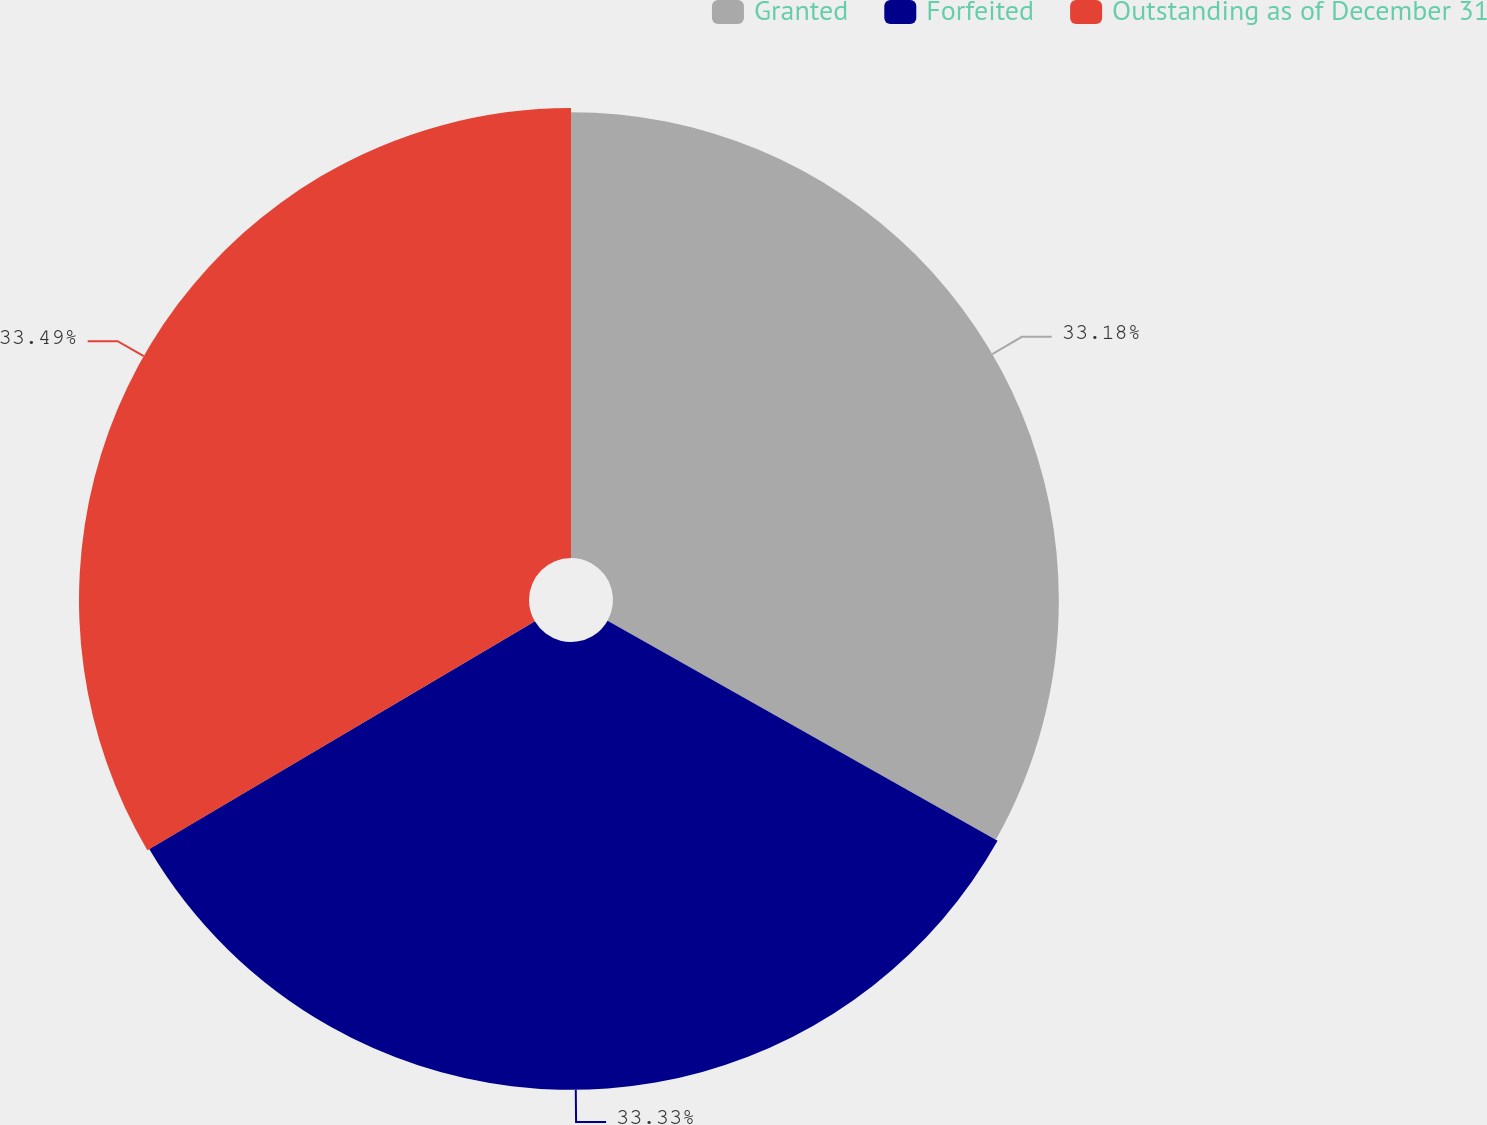Convert chart. <chart><loc_0><loc_0><loc_500><loc_500><pie_chart><fcel>Granted<fcel>Forfeited<fcel>Outstanding as of December 31<nl><fcel>33.18%<fcel>33.33%<fcel>33.49%<nl></chart> 